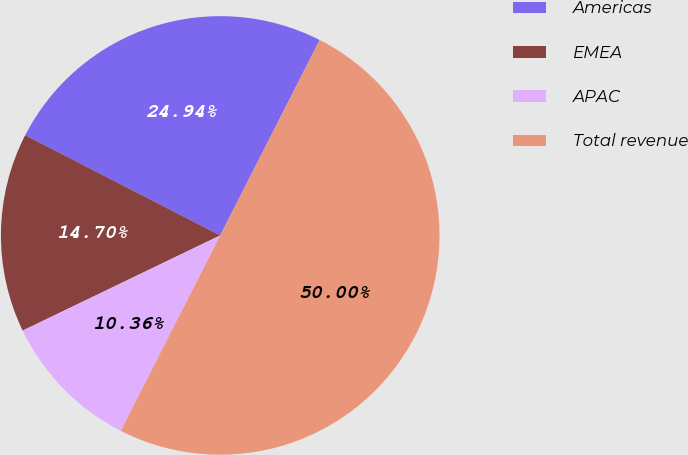<chart> <loc_0><loc_0><loc_500><loc_500><pie_chart><fcel>Americas<fcel>EMEA<fcel>APAC<fcel>Total revenue<nl><fcel>24.94%<fcel>14.7%<fcel>10.36%<fcel>50.0%<nl></chart> 